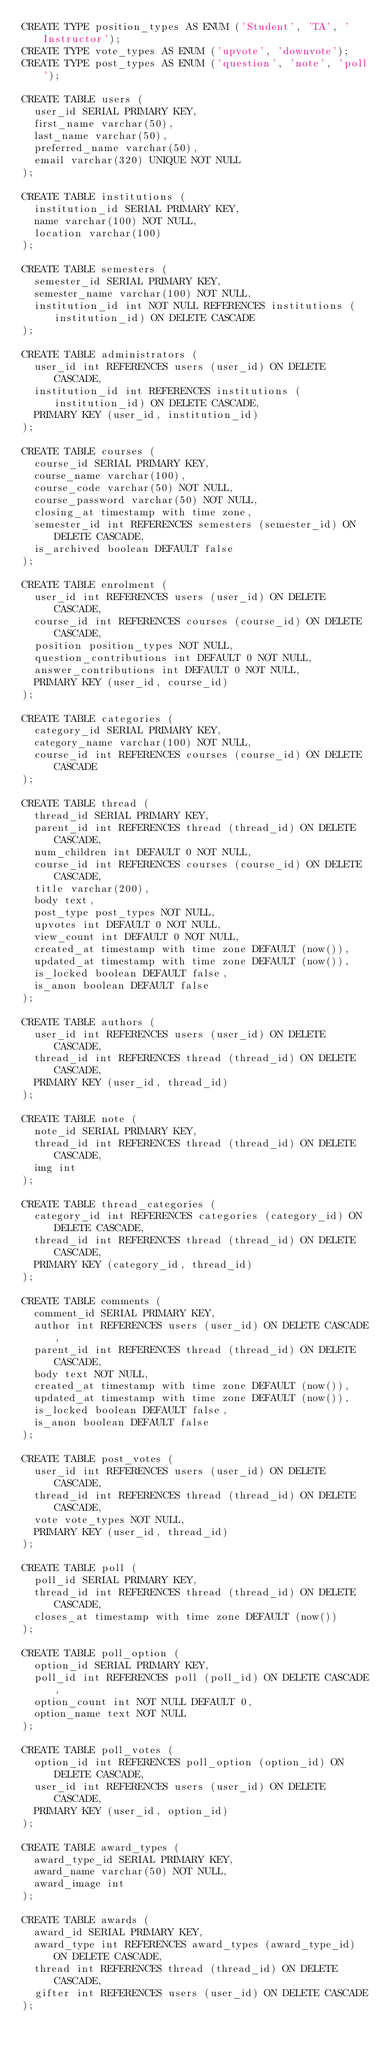<code> <loc_0><loc_0><loc_500><loc_500><_SQL_>CREATE TYPE position_types AS ENUM ('Student', 'TA', 'Instructor');
CREATE TYPE vote_types AS ENUM ('upvote', 'downvote');
CREATE TYPE post_types AS ENUM ('question', 'note', 'poll');

CREATE TABLE users (
  user_id SERIAL PRIMARY KEY,
  first_name varchar(50),
  last_name varchar(50),
  preferred_name varchar(50),
  email varchar(320) UNIQUE NOT NULL
);

CREATE TABLE institutions (
  institution_id SERIAL PRIMARY KEY,
  name varchar(100) NOT NULL,
  location varchar(100)
);

CREATE TABLE semesters (
  semester_id SERIAL PRIMARY KEY,
  semester_name varchar(100) NOT NULL,
  institution_id int NOT NULL REFERENCES institutions (institution_id) ON DELETE CASCADE
);

CREATE TABLE administrators (
  user_id int REFERENCES users (user_id) ON DELETE CASCADE,
  institution_id int REFERENCES institutions (institution_id) ON DELETE CASCADE,
  PRIMARY KEY (user_id, institution_id)
);

CREATE TABLE courses (
  course_id SERIAL PRIMARY KEY,
  course_name varchar(100),
  course_code varchar(50) NOT NULL,
  course_password varchar(50) NOT NULL,
  closing_at timestamp with time zone, 
  semester_id int REFERENCES semesters (semester_id) ON DELETE CASCADE,
  is_archived boolean DEFAULT false
);

CREATE TABLE enrolment (
  user_id int REFERENCES users (user_id) ON DELETE CASCADE,
  course_id int REFERENCES courses (course_id) ON DELETE CASCADE,
  position position_types NOT NULL,
  question_contributions int DEFAULT 0 NOT NULL,
  answer_contributions int DEFAULT 0 NOT NULL,
  PRIMARY KEY (user_id, course_id)
);

CREATE TABLE categories (
  category_id SERIAL PRIMARY KEY,
  category_name varchar(100) NOT NULL,
  course_id int REFERENCES courses (course_id) ON DELETE CASCADE
);

CREATE TABLE thread (
  thread_id SERIAL PRIMARY KEY,
  parent_id int REFERENCES thread (thread_id) ON DELETE CASCADE,
  num_children int DEFAULT 0 NOT NULL,
  course_id int REFERENCES courses (course_id) ON DELETE CASCADE,
  title varchar(200),
  body text,
  post_type post_types NOT NULL,
  upvotes int DEFAULT 0 NOT NULL,
  view_count int DEFAULT 0 NOT NULL,
  created_at timestamp with time zone DEFAULT (now()),
  updated_at timestamp with time zone DEFAULT (now()),
  is_locked boolean DEFAULT false,
  is_anon boolean DEFAULT false
);

CREATE TABLE authors (
  user_id int REFERENCES users (user_id) ON DELETE CASCADE,
  thread_id int REFERENCES thread (thread_id) ON DELETE CASCADE,
  PRIMARY KEY (user_id, thread_id)
);

CREATE TABLE note (
  note_id SERIAL PRIMARY KEY,
  thread_id int REFERENCES thread (thread_id) ON DELETE CASCADE,
  img int
);

CREATE TABLE thread_categories (
  category_id int REFERENCES categories (category_id) ON DELETE CASCADE,
  thread_id int REFERENCES thread (thread_id) ON DELETE CASCADE,
  PRIMARY KEY (category_id, thread_id)
);

CREATE TABLE comments (
  comment_id SERIAL PRIMARY KEY,
  author int REFERENCES users (user_id) ON DELETE CASCADE,
  parent_id int REFERENCES thread (thread_id) ON DELETE CASCADE,
  body text NOT NULL,
  created_at timestamp with time zone DEFAULT (now()),
  updated_at timestamp with time zone DEFAULT (now()),
  is_locked boolean DEFAULT false,
  is_anon boolean DEFAULT false
);

CREATE TABLE post_votes (
  user_id int REFERENCES users (user_id) ON DELETE CASCADE,
  thread_id int REFERENCES thread (thread_id) ON DELETE CASCADE,
  vote vote_types NOT NULL, 
  PRIMARY KEY (user_id, thread_id)
);

CREATE TABLE poll (
  poll_id SERIAL PRIMARY KEY,
  thread_id int REFERENCES thread (thread_id) ON DELETE CASCADE,
  closes_at timestamp with time zone DEFAULT (now())
);

CREATE TABLE poll_option (
  option_id SERIAL PRIMARY KEY,
  poll_id int REFERENCES poll (poll_id) ON DELETE CASCADE,
  option_count int NOT NULL DEFAULT 0,
  option_name text NOT NULL
);

CREATE TABLE poll_votes (
  option_id int REFERENCES poll_option (option_id) ON DELETE CASCADE,
  user_id int REFERENCES users (user_id) ON DELETE CASCADE,
  PRIMARY KEY (user_id, option_id)
);

CREATE TABLE award_types (
  award_type_id SERIAL PRIMARY KEY,
  award_name varchar(50) NOT NULL,
  award_image int
);

CREATE TABLE awards (
  award_id SERIAL PRIMARY KEY,
  award_type int REFERENCES award_types (award_type_id) ON DELETE CASCADE,
  thread int REFERENCES thread (thread_id) ON DELETE CASCADE,
  gifter int REFERENCES users (user_id) ON DELETE CASCADE
);
</code> 